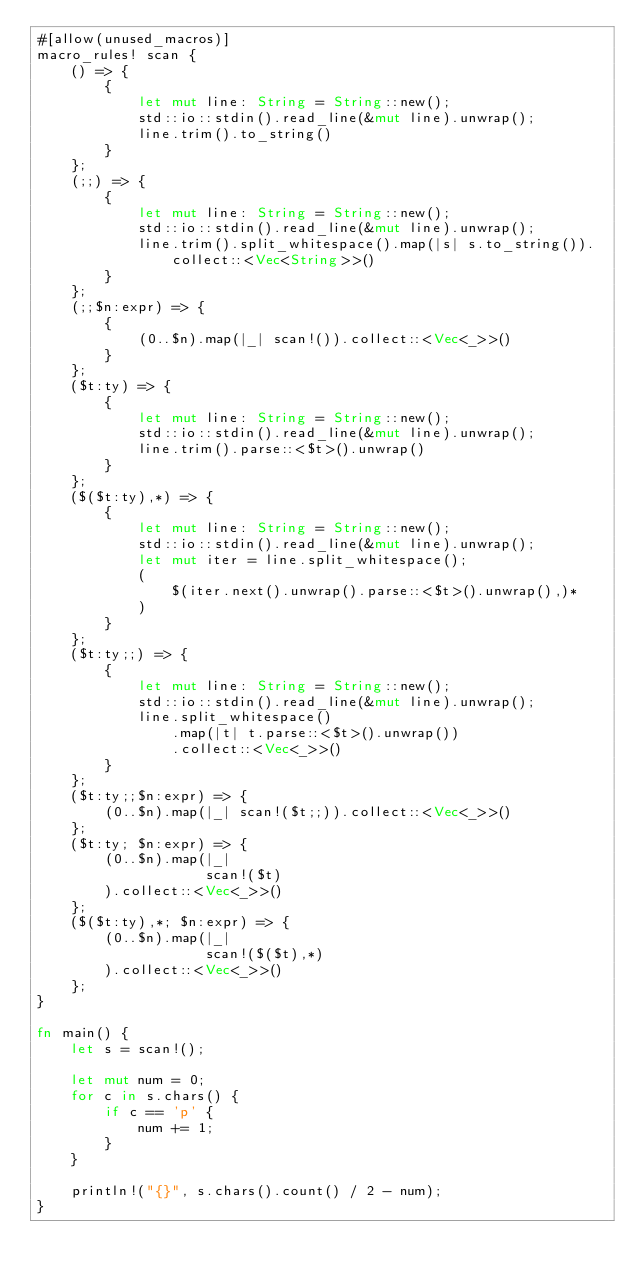<code> <loc_0><loc_0><loc_500><loc_500><_Rust_>#[allow(unused_macros)]
macro_rules! scan {
    () => {
        {
            let mut line: String = String::new();
            std::io::stdin().read_line(&mut line).unwrap();
            line.trim().to_string()
        }
    };
    (;;) => {
        {
            let mut line: String = String::new();
            std::io::stdin().read_line(&mut line).unwrap();
            line.trim().split_whitespace().map(|s| s.to_string()).collect::<Vec<String>>()
        }
    };
    (;;$n:expr) => {
        {
            (0..$n).map(|_| scan!()).collect::<Vec<_>>()
        }
    };
    ($t:ty) => {
        {
            let mut line: String = String::new();
            std::io::stdin().read_line(&mut line).unwrap();
            line.trim().parse::<$t>().unwrap()
        }
    };
    ($($t:ty),*) => {
        {
            let mut line: String = String::new();
            std::io::stdin().read_line(&mut line).unwrap();
            let mut iter = line.split_whitespace();
            (
                $(iter.next().unwrap().parse::<$t>().unwrap(),)*
            )
        }
    };
    ($t:ty;;) => {
        {
            let mut line: String = String::new();
            std::io::stdin().read_line(&mut line).unwrap();
            line.split_whitespace()
                .map(|t| t.parse::<$t>().unwrap())
                .collect::<Vec<_>>()
        }
    };
    ($t:ty;;$n:expr) => {
        (0..$n).map(|_| scan!($t;;)).collect::<Vec<_>>()
    };
    ($t:ty; $n:expr) => {
        (0..$n).map(|_|
                    scan!($t)
        ).collect::<Vec<_>>()
    };
    ($($t:ty),*; $n:expr) => {
        (0..$n).map(|_|
                    scan!($($t),*)
        ).collect::<Vec<_>>()
    };
}

fn main() {
    let s = scan!();

    let mut num = 0;
    for c in s.chars() {
        if c == 'p' {
            num += 1;
        }
    }

    println!("{}", s.chars().count() / 2 - num);
}
</code> 